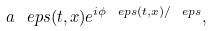Convert formula to latex. <formula><loc_0><loc_0><loc_500><loc_500>a ^ { \ } e p s ( t , x ) e ^ { i \phi ^ { \ } e p s ( t , x ) / \ e p s } ,</formula> 